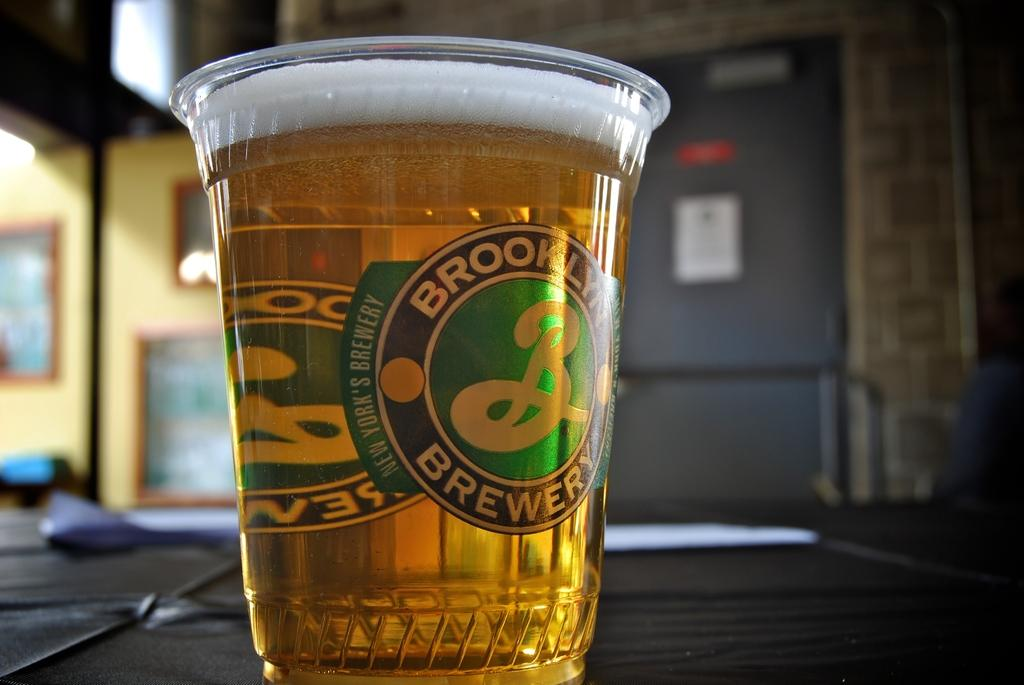Provide a one-sentence caption for the provided image. Brooklyn Brewery has a cup which beer can be served in. 